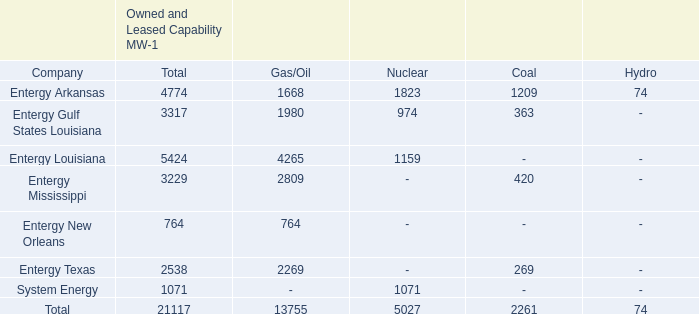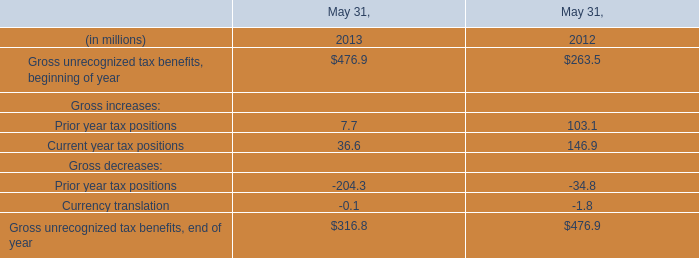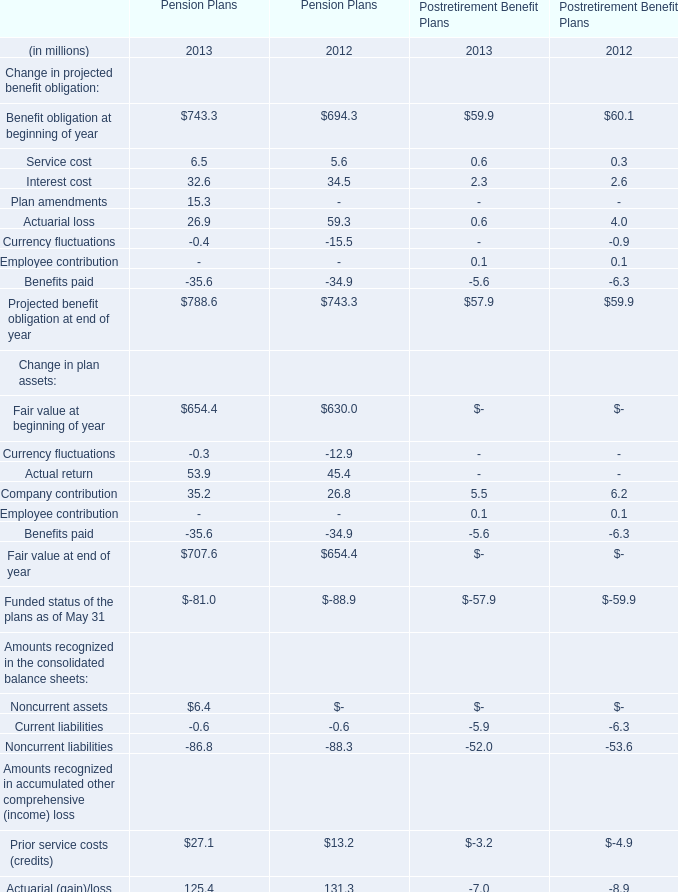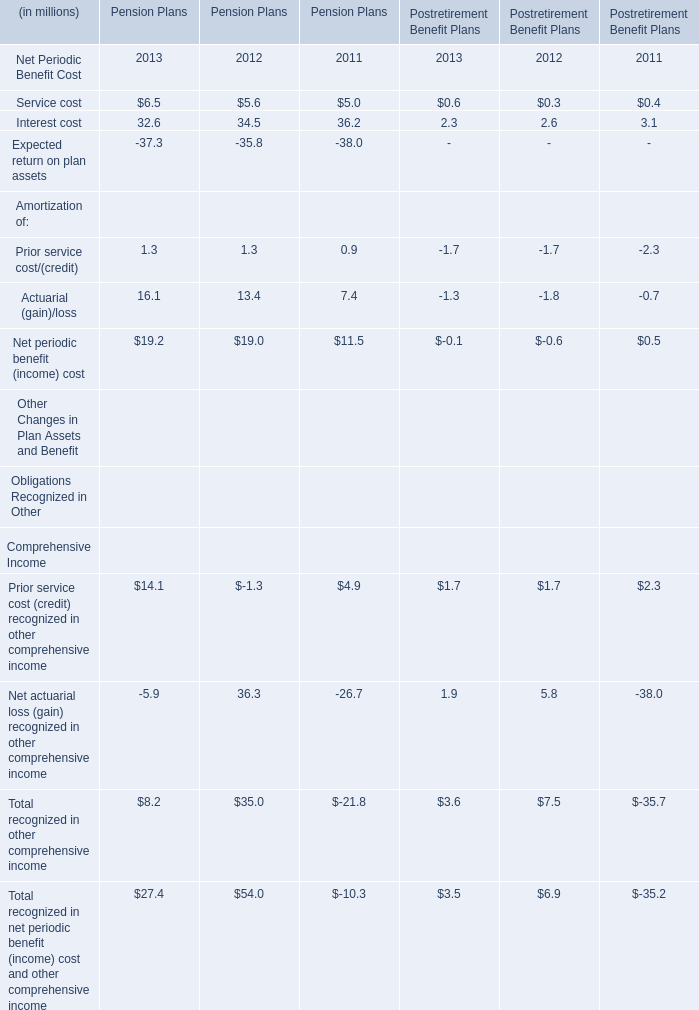What is the sum of the Fair value at beginning of year in the years where Service cost is positive? (in million) 
Computations: (654.4 + 630.0)
Answer: 1284.4. 